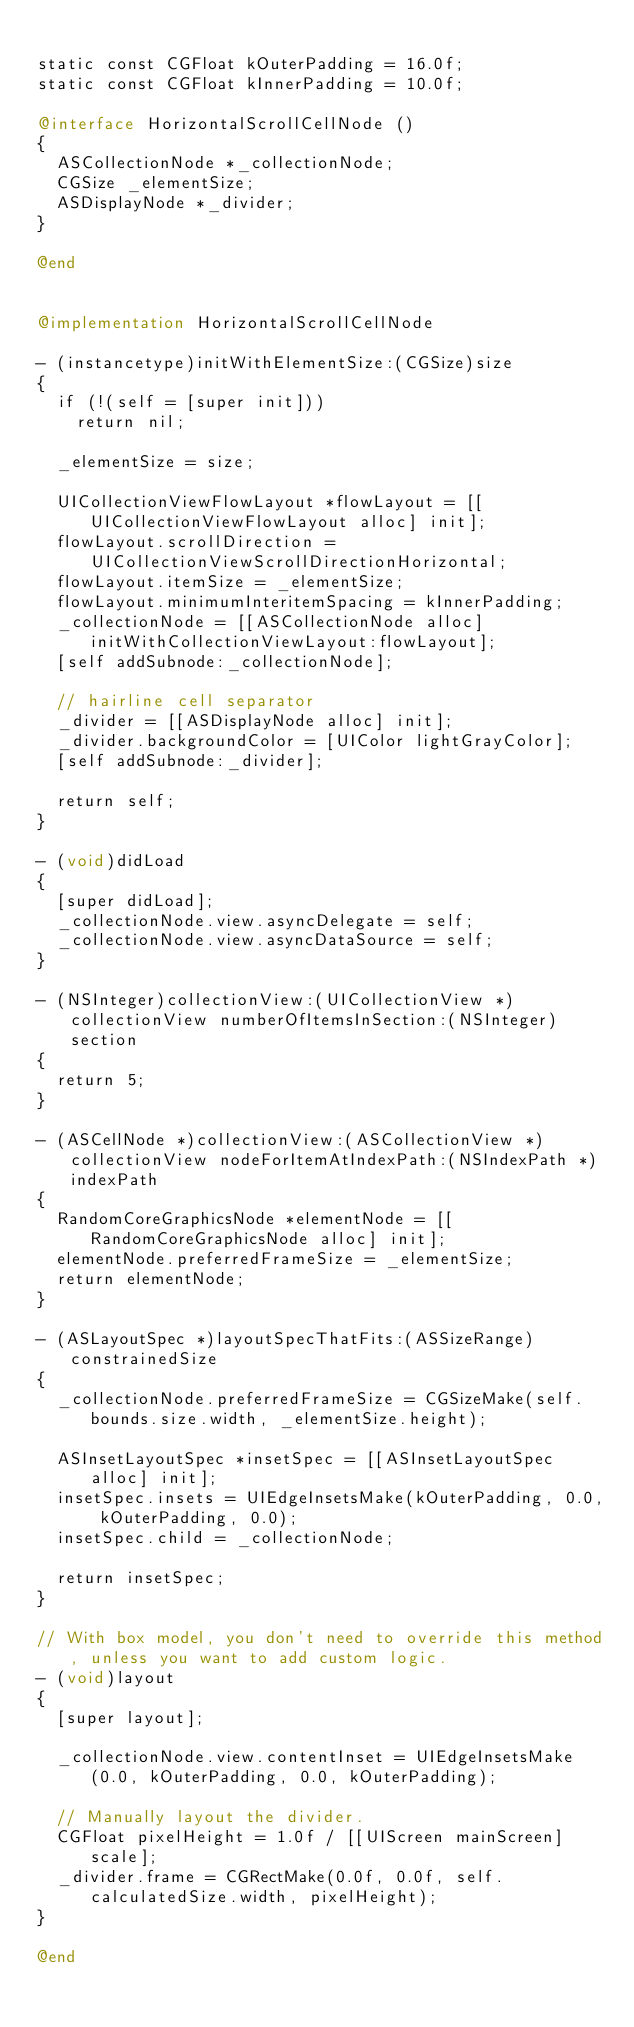<code> <loc_0><loc_0><loc_500><loc_500><_ObjectiveC_>
static const CGFloat kOuterPadding = 16.0f;
static const CGFloat kInnerPadding = 10.0f;

@interface HorizontalScrollCellNode ()
{
  ASCollectionNode *_collectionNode;
  CGSize _elementSize;
  ASDisplayNode *_divider;
}

@end


@implementation HorizontalScrollCellNode

- (instancetype)initWithElementSize:(CGSize)size
{
  if (!(self = [super init]))
    return nil;

  _elementSize = size;

  UICollectionViewFlowLayout *flowLayout = [[UICollectionViewFlowLayout alloc] init];
  flowLayout.scrollDirection = UICollectionViewScrollDirectionHorizontal;
  flowLayout.itemSize = _elementSize;
  flowLayout.minimumInteritemSpacing = kInnerPadding;
  _collectionNode = [[ASCollectionNode alloc] initWithCollectionViewLayout:flowLayout];
  [self addSubnode:_collectionNode];
  
  // hairline cell separator
  _divider = [[ASDisplayNode alloc] init];
  _divider.backgroundColor = [UIColor lightGrayColor];
  [self addSubnode:_divider];

  return self;
}

- (void)didLoad
{
  [super didLoad];
  _collectionNode.view.asyncDelegate = self;
  _collectionNode.view.asyncDataSource = self;
}

- (NSInteger)collectionView:(UICollectionView *)collectionView numberOfItemsInSection:(NSInteger)section
{
  return 5;
}

- (ASCellNode *)collectionView:(ASCollectionView *)collectionView nodeForItemAtIndexPath:(NSIndexPath *)indexPath
{
  RandomCoreGraphicsNode *elementNode = [[RandomCoreGraphicsNode alloc] init];
  elementNode.preferredFrameSize = _elementSize;
  return elementNode;
}

- (ASLayoutSpec *)layoutSpecThatFits:(ASSizeRange)constrainedSize
{
  _collectionNode.preferredFrameSize = CGSizeMake(self.bounds.size.width, _elementSize.height);
  
  ASInsetLayoutSpec *insetSpec = [[ASInsetLayoutSpec alloc] init];
  insetSpec.insets = UIEdgeInsetsMake(kOuterPadding, 0.0, kOuterPadding, 0.0);
  insetSpec.child = _collectionNode;
  
  return insetSpec;
}

// With box model, you don't need to override this method, unless you want to add custom logic.
- (void)layout
{
  [super layout];
  
  _collectionNode.view.contentInset = UIEdgeInsetsMake(0.0, kOuterPadding, 0.0, kOuterPadding);
  
  // Manually layout the divider.
  CGFloat pixelHeight = 1.0f / [[UIScreen mainScreen] scale];
  _divider.frame = CGRectMake(0.0f, 0.0f, self.calculatedSize.width, pixelHeight);
}

@end
</code> 